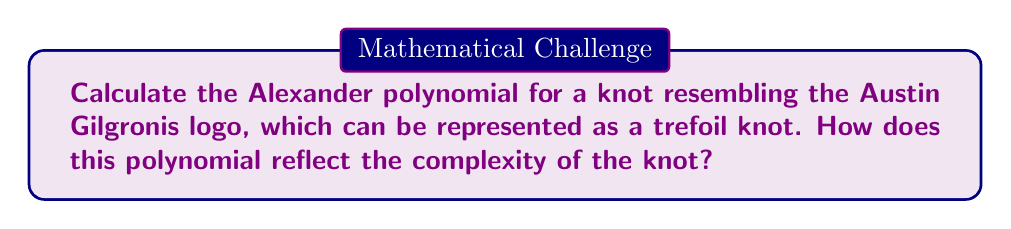Solve this math problem. Let's approach this step-by-step:

1) First, we need to draw the trefoil knot diagram:

[asy]
import geometry;

path p = (0,0)..(-1,1)..(0,2)..(1,1)..(0,0);
draw(p, linewidth(2));
draw(p, linewidth(2)+white, subpath(p,0.1,0.9));
draw(p, linewidth(2), subpath(p,0.3,0.7));

label("a", (-0.5,0.5), E);
label("b", (0.5,0.5), W);
label("c", (0,1.5), E);
[/asy]

2) We label the arcs of the knot as a, b, and c.

3) Now, we create the Alexander matrix. For a trefoil knot, this is a 2x2 matrix:

$$ \begin{pmatrix}
1-t & t \\
t & 1-t
\end{pmatrix} $$

4) The Alexander polynomial is the determinant of this matrix:

$$ \Delta(t) = \det \begin{pmatrix}
1-t & t \\
t & 1-t
\end{pmatrix} $$

5) Calculate the determinant:

$$ \Delta(t) = (1-t)(1-t) - t^2 $$

6) Simplify:

$$ \Delta(t) = 1-2t+t^2-t^2 = 1-2t+0 $$

7) Therefore, the Alexander polynomial for the trefoil knot is:

$$ \Delta(t) = 1-t+t^2 $$

This polynomial reflects the complexity of the knot in several ways:
- It's not constant, indicating the knot is non-trivial.
- The degree of the polynomial (2) corresponds to the crossing number of the knot (3) minus 1.
- The coefficients are symmetric, which is a property of all Alexander polynomials.
Answer: $\Delta(t) = 1-t+t^2$ 